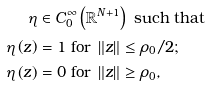<formula> <loc_0><loc_0><loc_500><loc_500>\eta & \in C _ { 0 } ^ { \infty } \left ( \mathbb { R } ^ { N + 1 } \right ) \text { such that} \\ \eta \left ( z \right ) & = 1 \text { for } \left \| z \right \| \leq \rho _ { 0 } / 2 ; \\ \eta \left ( z \right ) & = 0 \text { for } \left \| z \right \| \geq \rho _ { 0 } ,</formula> 